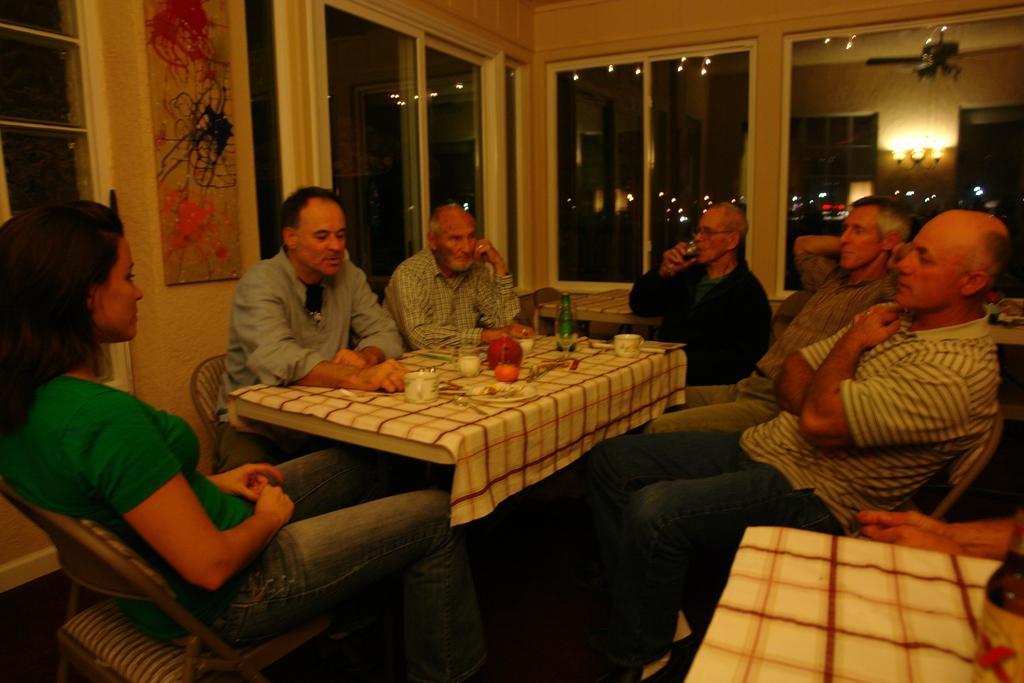Describe this image in one or two sentences. In this image there are so many people sitting around the table on which we can see there is a cloth and some food stuff. 